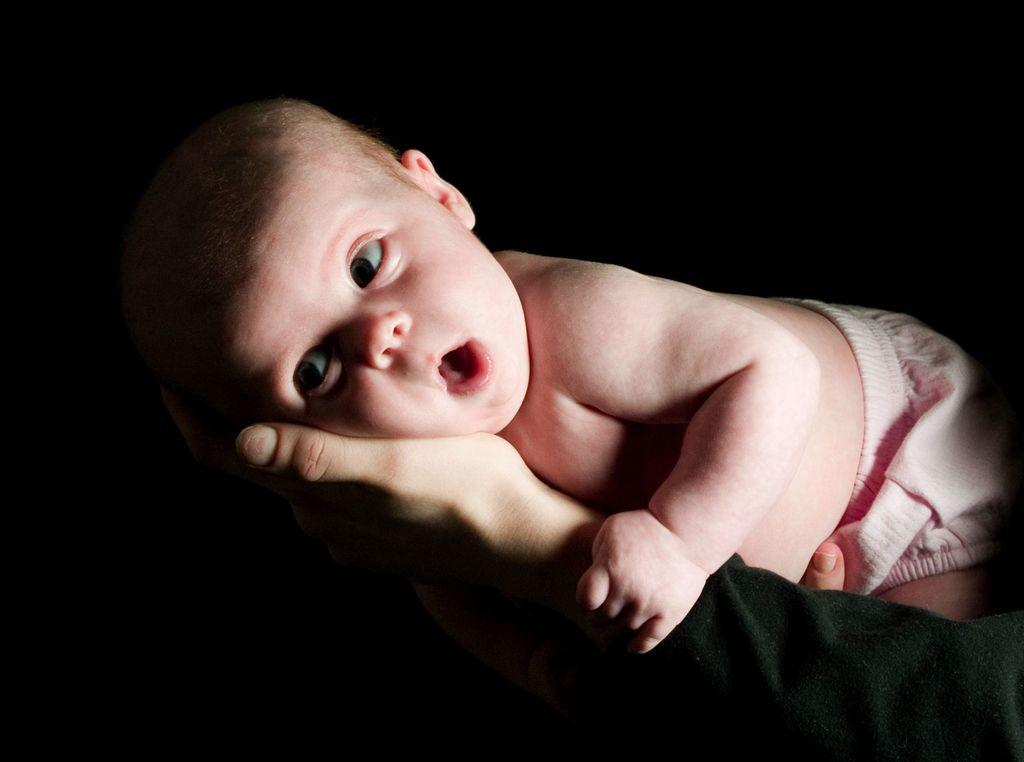What is the main subject of the image? There is a baby in the image. How is the baby being held or supported in the image? The baby is lying on a person's hands. What can be observed about the lighting or color of the background in the image? The background of the image appears to be dark. What type of house is visible in the background of the image? There is no house visible in the background of the image; it appears to be dark. What songs is the baby singing in the image? The baby is not singing any songs in the image; they are lying on a person's hands. 